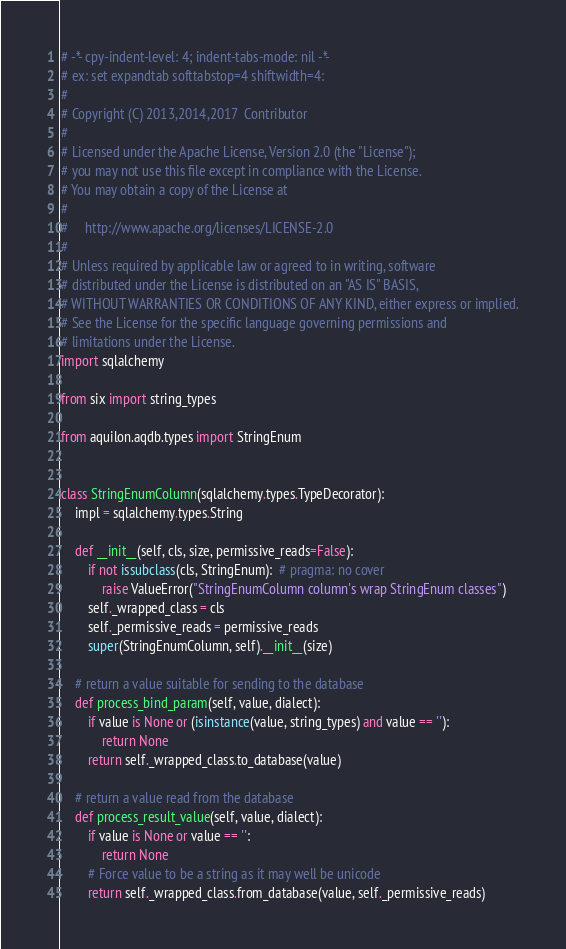Convert code to text. <code><loc_0><loc_0><loc_500><loc_500><_Python_># -*- cpy-indent-level: 4; indent-tabs-mode: nil -*-
# ex: set expandtab softtabstop=4 shiftwidth=4:
#
# Copyright (C) 2013,2014,2017  Contributor
#
# Licensed under the Apache License, Version 2.0 (the "License");
# you may not use this file except in compliance with the License.
# You may obtain a copy of the License at
#
#     http://www.apache.org/licenses/LICENSE-2.0
#
# Unless required by applicable law or agreed to in writing, software
# distributed under the License is distributed on an "AS IS" BASIS,
# WITHOUT WARRANTIES OR CONDITIONS OF ANY KIND, either express or implied.
# See the License for the specific language governing permissions and
# limitations under the License.
import sqlalchemy

from six import string_types

from aquilon.aqdb.types import StringEnum


class StringEnumColumn(sqlalchemy.types.TypeDecorator):
    impl = sqlalchemy.types.String

    def __init__(self, cls, size, permissive_reads=False):
        if not issubclass(cls, StringEnum):  # pragma: no cover
            raise ValueError("StringEnumColumn column's wrap StringEnum classes")
        self._wrapped_class = cls
        self._permissive_reads = permissive_reads
        super(StringEnumColumn, self).__init__(size)

    # return a value suitable for sending to the database
    def process_bind_param(self, value, dialect):
        if value is None or (isinstance(value, string_types) and value == ''):
            return None
        return self._wrapped_class.to_database(value)

    # return a value read from the database
    def process_result_value(self, value, dialect):
        if value is None or value == '':
            return None
        # Force value to be a string as it may well be unicode
        return self._wrapped_class.from_database(value, self._permissive_reads)
</code> 